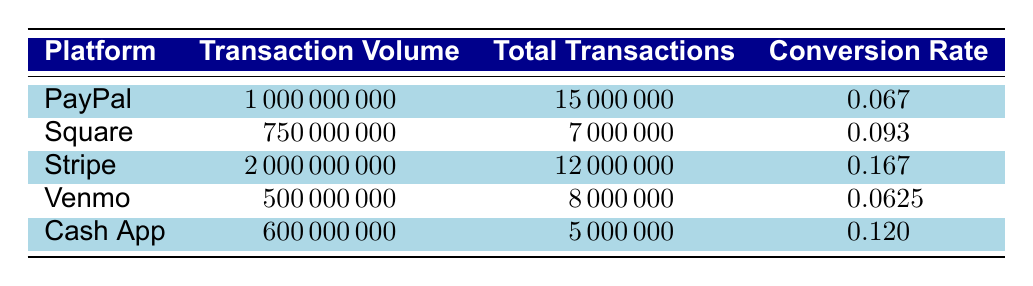What is the transaction volume for Stripe? The table shows a row for Stripe, where the transaction volume is explicitly listed. By referencing that row, we can directly find that the transaction volume for Stripe is 2000000000.
Answer: 2000000000 Which platform has the highest conversion rate? Looking at the conversion rates in the table, we can see the rates listed as follows: PayPal (0.067), Square (0.093), Stripe (0.167), Venmo (0.0625), and Cash App (0.12). Comparing these values, Stripe has the highest conversion rate of 0.167.
Answer: Stripe What is the total transaction volume of PayPal and Cash App combined? First, we find the transaction volume for PayPal, which is 1000000000, and for Cash App, which is 600000000. Adding these values together gives 1000000000 + 600000000 = 1600000000.
Answer: 1600000000 Is the conversion rate for Venmo greater than 0.07? The conversion rate for Venmo as stated in the table is 0.0625. Since 0.0625 is less than 0.07, the answer is no.
Answer: No Which platform has the fewest total transactions, and what is that number? The total transactions for each platform can be extracted from the table: PayPal (15000000), Square (7000000), Stripe (12000000), Venmo (8000000), and Cash App (5000000). By comparing these numbers, Cash App has the fewest total transactions with 5000000.
Answer: 5000000 What is the average conversion rate of all platforms? To find the average conversion rate, we sum the individual conversion rates: 0.067 + 0.093 + 0.167 + 0.0625 + 0.12 = 0.5095. Next, we divide this sum by the number of platforms (5): 0.5095 / 5 = 0.1019. Thus, the average conversion rate is approximately 0.1019.
Answer: 0.1019 Is it true that Square has a higher conversion rate than Venmo? The conversion rates are listed as Square (0.093) and Venmo (0.0625). Since 0.093 is greater than 0.0625, the statement is true.
Answer: Yes Which two payment platforms combined have a transaction volume greater than 1 billion? We can compare combinations of platforms: PayPal (1000000000), Square (750000000), Stripe (2000000000), Venmo (500000000), and Cash App (600000000). The only combinations where the total surpasses 1 billion are Stripe alone (2000000000) and PayPal + Square (1000000000 + 750000000 = 1750000000). Therefore, both Stripe alone and the combination of PayPal and Square work.
Answer: Stripe; PayPal and Square What is the total transaction volume of platforms that have a conversion rate above 0.1? The conversion rates that exceed 0.1 are for Stripe (0.167) and Cash App (0.12). Their transaction volumes are 2000000000 (Stripe) and 600000000 (Cash App). Adding these gives 2000000000 + 600000000 = 2600000000.
Answer: 2600000000 